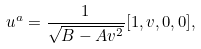Convert formula to latex. <formula><loc_0><loc_0><loc_500><loc_500>u ^ { a } = \frac { 1 } { \sqrt { B - A v ^ { 2 } } } [ 1 , v , 0 , 0 ] ,</formula> 